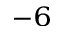<formula> <loc_0><loc_0><loc_500><loc_500>^ { - 6 }</formula> 